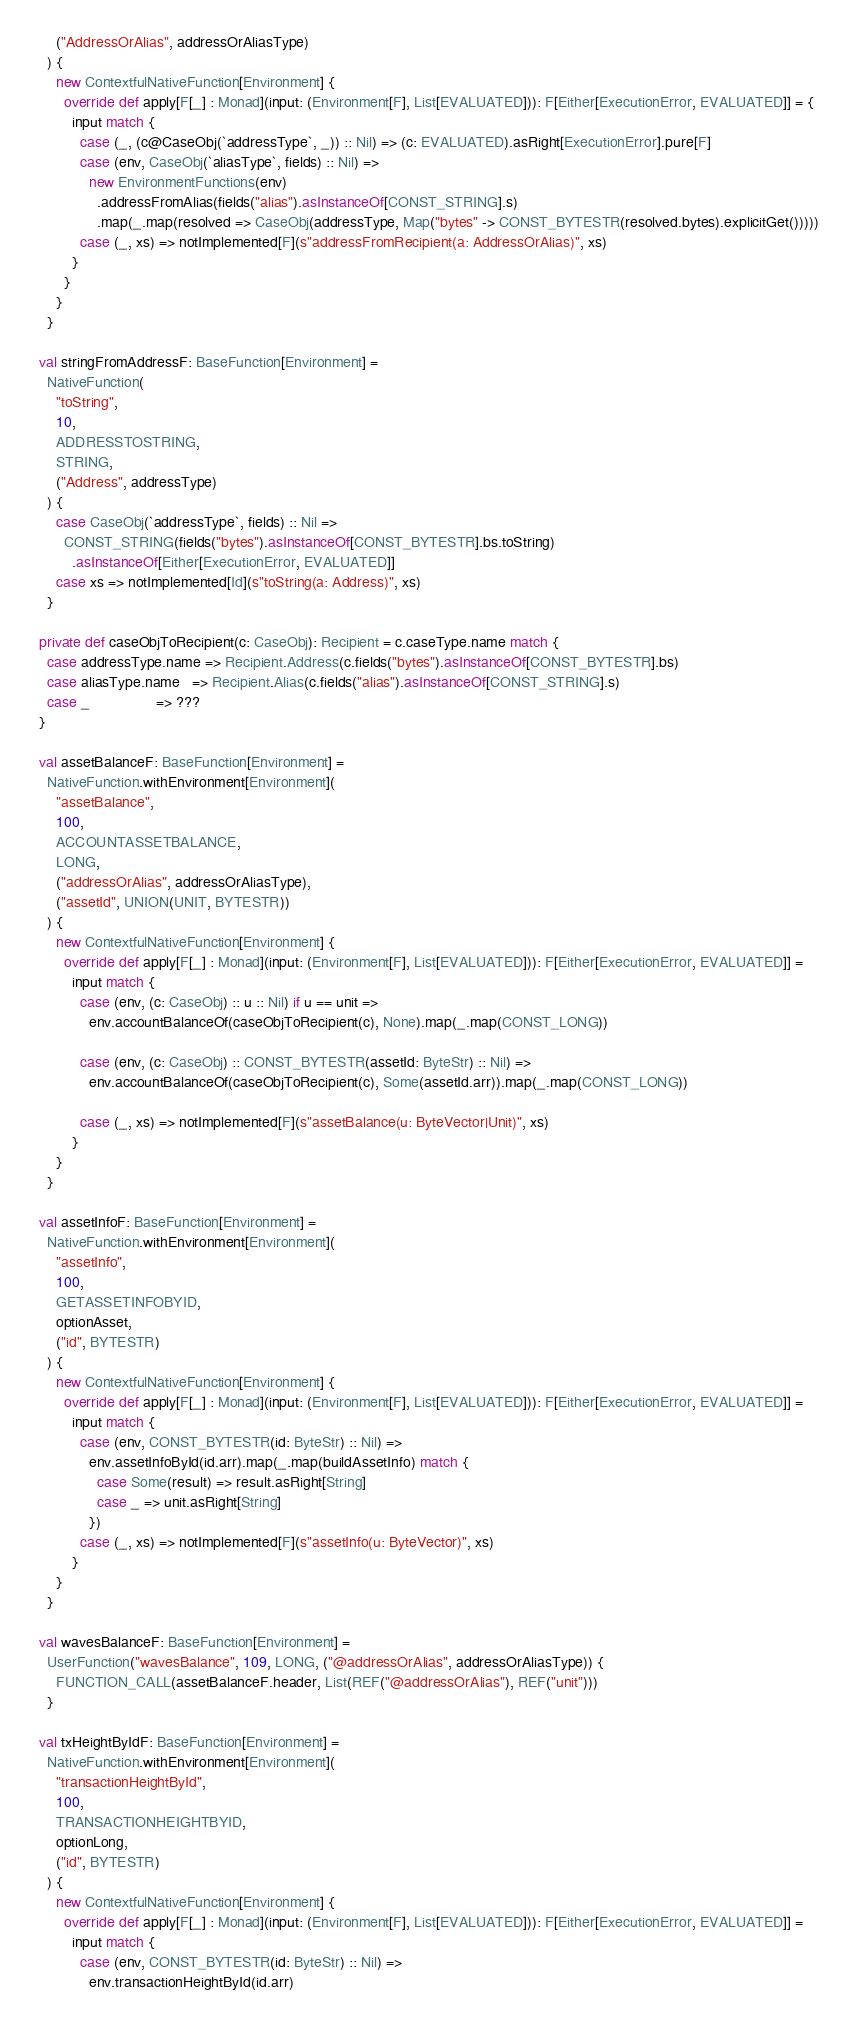<code> <loc_0><loc_0><loc_500><loc_500><_Scala_>      ("AddressOrAlias", addressOrAliasType)
    ) {
      new ContextfulNativeFunction[Environment] {
        override def apply[F[_] : Monad](input: (Environment[F], List[EVALUATED])): F[Either[ExecutionError, EVALUATED]] = {
          input match {
            case (_, (c@CaseObj(`addressType`, _)) :: Nil) => (c: EVALUATED).asRight[ExecutionError].pure[F]
            case (env, CaseObj(`aliasType`, fields) :: Nil) =>
              new EnvironmentFunctions(env)
                .addressFromAlias(fields("alias").asInstanceOf[CONST_STRING].s)
                .map(_.map(resolved => CaseObj(addressType, Map("bytes" -> CONST_BYTESTR(resolved.bytes).explicitGet()))))
            case (_, xs) => notImplemented[F](s"addressFromRecipient(a: AddressOrAlias)", xs)
          }
        }
      }
    }

  val stringFromAddressF: BaseFunction[Environment] =
    NativeFunction(
      "toString",
      10,
      ADDRESSTOSTRING,
      STRING,
      ("Address", addressType)
    ) {
      case CaseObj(`addressType`, fields) :: Nil =>
        CONST_STRING(fields("bytes").asInstanceOf[CONST_BYTESTR].bs.toString)
          .asInstanceOf[Either[ExecutionError, EVALUATED]]
      case xs => notImplemented[Id](s"toString(a: Address)", xs)
    }

  private def caseObjToRecipient(c: CaseObj): Recipient = c.caseType.name match {
    case addressType.name => Recipient.Address(c.fields("bytes").asInstanceOf[CONST_BYTESTR].bs)
    case aliasType.name   => Recipient.Alias(c.fields("alias").asInstanceOf[CONST_STRING].s)
    case _                => ???
  }

  val assetBalanceF: BaseFunction[Environment] =
    NativeFunction.withEnvironment[Environment](
      "assetBalance",
      100,
      ACCOUNTASSETBALANCE,
      LONG,
      ("addressOrAlias", addressOrAliasType),
      ("assetId", UNION(UNIT, BYTESTR))
    ) {
      new ContextfulNativeFunction[Environment] {
        override def apply[F[_] : Monad](input: (Environment[F], List[EVALUATED])): F[Either[ExecutionError, EVALUATED]] =
          input match {
            case (env, (c: CaseObj) :: u :: Nil) if u == unit =>
              env.accountBalanceOf(caseObjToRecipient(c), None).map(_.map(CONST_LONG))

            case (env, (c: CaseObj) :: CONST_BYTESTR(assetId: ByteStr) :: Nil) =>
              env.accountBalanceOf(caseObjToRecipient(c), Some(assetId.arr)).map(_.map(CONST_LONG))

            case (_, xs) => notImplemented[F](s"assetBalance(u: ByteVector|Unit)", xs)
          }
      }
    }

  val assetInfoF: BaseFunction[Environment] =
    NativeFunction.withEnvironment[Environment](
      "assetInfo",
      100,
      GETASSETINFOBYID,
      optionAsset,
      ("id", BYTESTR)
    ) {
      new ContextfulNativeFunction[Environment] {
        override def apply[F[_] : Monad](input: (Environment[F], List[EVALUATED])): F[Either[ExecutionError, EVALUATED]] =
          input match {
            case (env, CONST_BYTESTR(id: ByteStr) :: Nil) =>
              env.assetInfoById(id.arr).map(_.map(buildAssetInfo) match {
                case Some(result) => result.asRight[String]
                case _ => unit.asRight[String]
              })
            case (_, xs) => notImplemented[F](s"assetInfo(u: ByteVector)", xs)
          }
      }
    }

  val wavesBalanceF: BaseFunction[Environment] =
    UserFunction("wavesBalance", 109, LONG, ("@addressOrAlias", addressOrAliasType)) {
      FUNCTION_CALL(assetBalanceF.header, List(REF("@addressOrAlias"), REF("unit")))
    }

  val txHeightByIdF: BaseFunction[Environment] =
    NativeFunction.withEnvironment[Environment](
      "transactionHeightById",
      100,
      TRANSACTIONHEIGHTBYID,
      optionLong,
      ("id", BYTESTR)
    ) {
      new ContextfulNativeFunction[Environment] {
        override def apply[F[_] : Monad](input: (Environment[F], List[EVALUATED])): F[Either[ExecutionError, EVALUATED]] =
          input match {
            case (env, CONST_BYTESTR(id: ByteStr) :: Nil) =>
              env.transactionHeightById(id.arr)</code> 